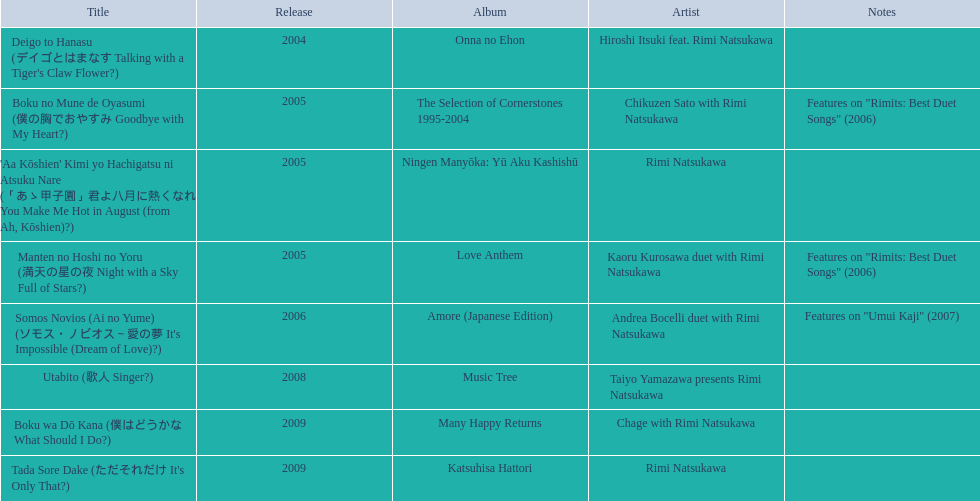What are all of the titles? Deigo to Hanasu (デイゴとはまなす Talking with a Tiger's Claw Flower?), Boku no Mune de Oyasumi (僕の胸でおやすみ Goodbye with My Heart?), 'Aa Kōshien' Kimi yo Hachigatsu ni Atsuku Nare (「あゝ甲子園」君よ八月に熱くなれ You Make Me Hot in August (from Ah, Kōshien)?), Manten no Hoshi no Yoru (満天の星の夜 Night with a Sky Full of Stars?), Somos Novios (Ai no Yume) (ソモス・ノビオス～愛の夢 It's Impossible (Dream of Love)?), Utabito (歌人 Singer?), Boku wa Dō Kana (僕はどうかな What Should I Do?), Tada Sore Dake (ただそれだけ It's Only That?). What are their notes? , Features on "Rimits: Best Duet Songs" (2006), , Features on "Rimits: Best Duet Songs" (2006), Features on "Umui Kaji" (2007), , , . Which title shares its notes with manten no hoshi no yoru (man tian noxing noye night with a sky full of stars?)? Boku no Mune de Oyasumi (僕の胸でおやすみ Goodbye with My Heart?). 